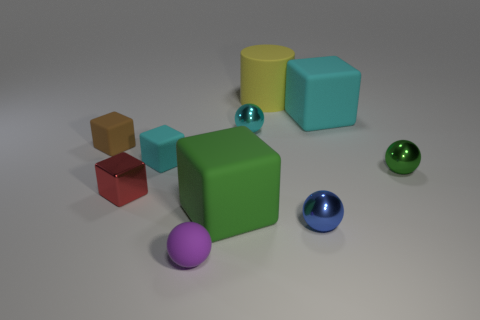Subtract all green cubes. How many cubes are left? 4 Subtract all metal blocks. How many blocks are left? 4 Subtract all blue blocks. Subtract all cyan cylinders. How many blocks are left? 5 Subtract all cylinders. How many objects are left? 9 Subtract 0 purple blocks. How many objects are left? 10 Subtract all matte spheres. Subtract all green cylinders. How many objects are left? 9 Add 1 tiny red metal objects. How many tiny red metal objects are left? 2 Add 6 matte cubes. How many matte cubes exist? 10 